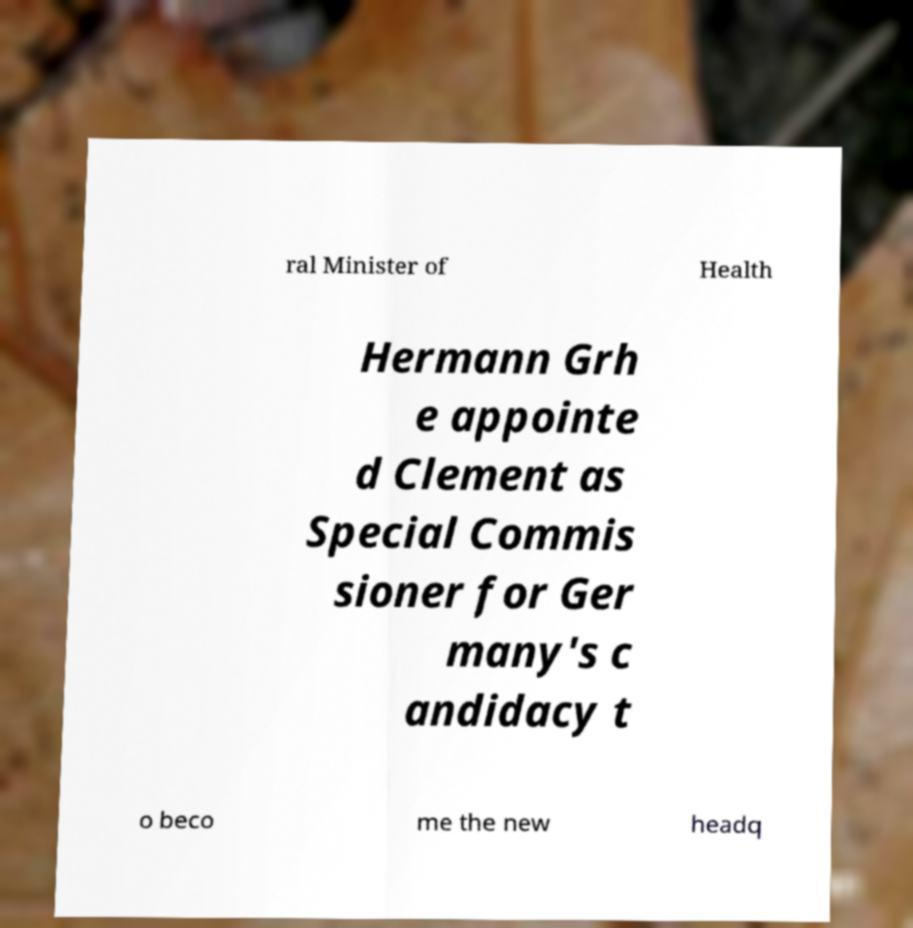Could you extract and type out the text from this image? ral Minister of Health Hermann Grh e appointe d Clement as Special Commis sioner for Ger many's c andidacy t o beco me the new headq 